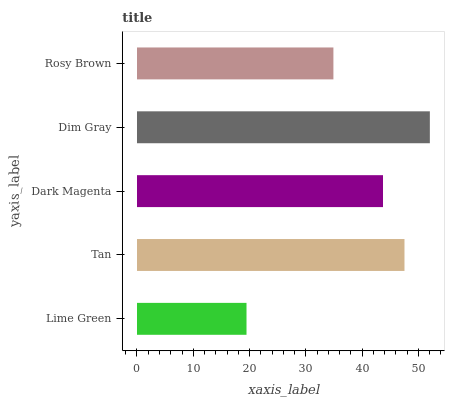Is Lime Green the minimum?
Answer yes or no. Yes. Is Dim Gray the maximum?
Answer yes or no. Yes. Is Tan the minimum?
Answer yes or no. No. Is Tan the maximum?
Answer yes or no. No. Is Tan greater than Lime Green?
Answer yes or no. Yes. Is Lime Green less than Tan?
Answer yes or no. Yes. Is Lime Green greater than Tan?
Answer yes or no. No. Is Tan less than Lime Green?
Answer yes or no. No. Is Dark Magenta the high median?
Answer yes or no. Yes. Is Dark Magenta the low median?
Answer yes or no. Yes. Is Dim Gray the high median?
Answer yes or no. No. Is Rosy Brown the low median?
Answer yes or no. No. 